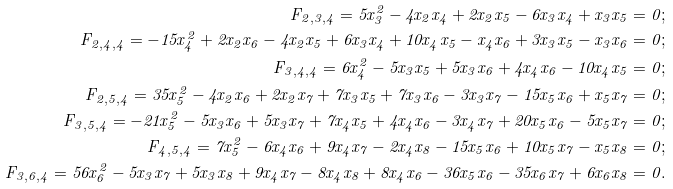<formula> <loc_0><loc_0><loc_500><loc_500>F _ { 2 , 3 , 4 } = 5 x _ { 3 } ^ { 2 } - 4 x _ { 2 } x _ { 4 } + 2 x _ { 2 } x _ { 5 } - 6 x _ { 3 } x _ { 4 } + x _ { 3 } x _ { 5 } = 0 ; \\ F _ { 2 , 4 , 4 } = - 1 5 x _ { 4 } ^ { 2 } + 2 x _ { 2 } x _ { 6 } - 4 x _ { 2 } x _ { 5 } + 6 x _ { 3 } x _ { 4 } + 1 0 x _ { 4 } x _ { 5 } - x _ { 4 } x _ { 6 } + 3 x _ { 3 } x _ { 5 } - x _ { 3 } x _ { 6 } = 0 ; \\ F _ { 3 , 4 , 4 } = 6 x _ { 4 } ^ { 2 } - 5 x _ { 3 } x _ { 5 } + 5 x _ { 3 } x _ { 6 } + 4 x _ { 4 } x _ { 6 } - 1 0 x _ { 4 } x _ { 5 } = 0 ; \\ F _ { 2 , 5 , 4 } = 3 5 x _ { 5 } ^ { 2 } - 4 x _ { 2 } x _ { 6 } + 2 x _ { 2 } x _ { 7 } + 7 x _ { 3 } x _ { 5 } + 7 x _ { 3 } x _ { 6 } - 3 x _ { 3 } x _ { 7 } - 1 5 x _ { 5 } x _ { 6 } + x _ { 5 } x _ { 7 } = 0 ; \\ F _ { 3 , 5 , 4 } = - 2 1 x _ { 5 } ^ { 2 } - 5 x _ { 3 } x _ { 6 } + 5 x _ { 3 } x _ { 7 } + 7 x _ { 4 } x _ { 5 } + 4 x _ { 4 } x _ { 6 } - 3 x _ { 4 } x _ { 7 } + 2 0 x _ { 5 } x _ { 6 } - 5 x _ { 5 } x _ { 7 } = 0 ; \\ F _ { 4 , 5 , 4 } = 7 x _ { 5 } ^ { 2 } - 6 x _ { 4 } x _ { 6 } + 9 x _ { 4 } x _ { 7 } - 2 x _ { 4 } x _ { 8 } - 1 5 x _ { 5 } x _ { 6 } + 1 0 x _ { 5 } x _ { 7 } - x _ { 5 } x _ { 8 } = 0 ; \\ F _ { 3 , 6 , 4 } = 5 6 x _ { 6 } ^ { 2 } - 5 x _ { 3 } x _ { 7 } + 5 x _ { 3 } x _ { 8 } + 9 x _ { 4 } x _ { 7 } - 8 x _ { 4 } x _ { 8 } + 8 x _ { 4 } x _ { 6 } - 3 6 x _ { 5 } x _ { 6 } - 3 5 x _ { 6 } x _ { 7 } + 6 x _ { 6 } x _ { 8 } = 0 . \\</formula> 